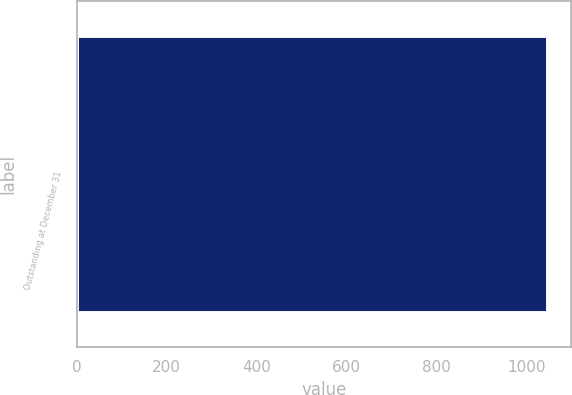Convert chart to OTSL. <chart><loc_0><loc_0><loc_500><loc_500><bar_chart><fcel>Outstanding at December 31<nl><fcel>1046<nl></chart> 